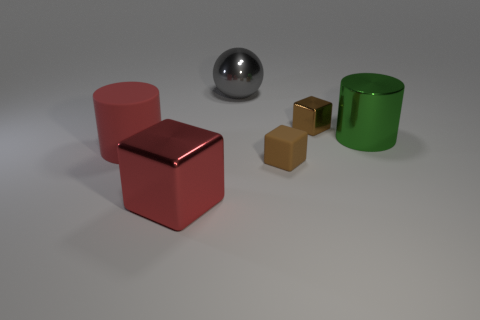Subtract all green cylinders. Subtract all brown blocks. How many cylinders are left? 1 Add 2 gray objects. How many objects exist? 8 Subtract all cylinders. How many objects are left? 4 Subtract all big metal cubes. Subtract all big rubber cylinders. How many objects are left? 4 Add 2 small blocks. How many small blocks are left? 4 Add 6 tiny brown metallic objects. How many tiny brown metallic objects exist? 7 Subtract 0 cyan blocks. How many objects are left? 6 